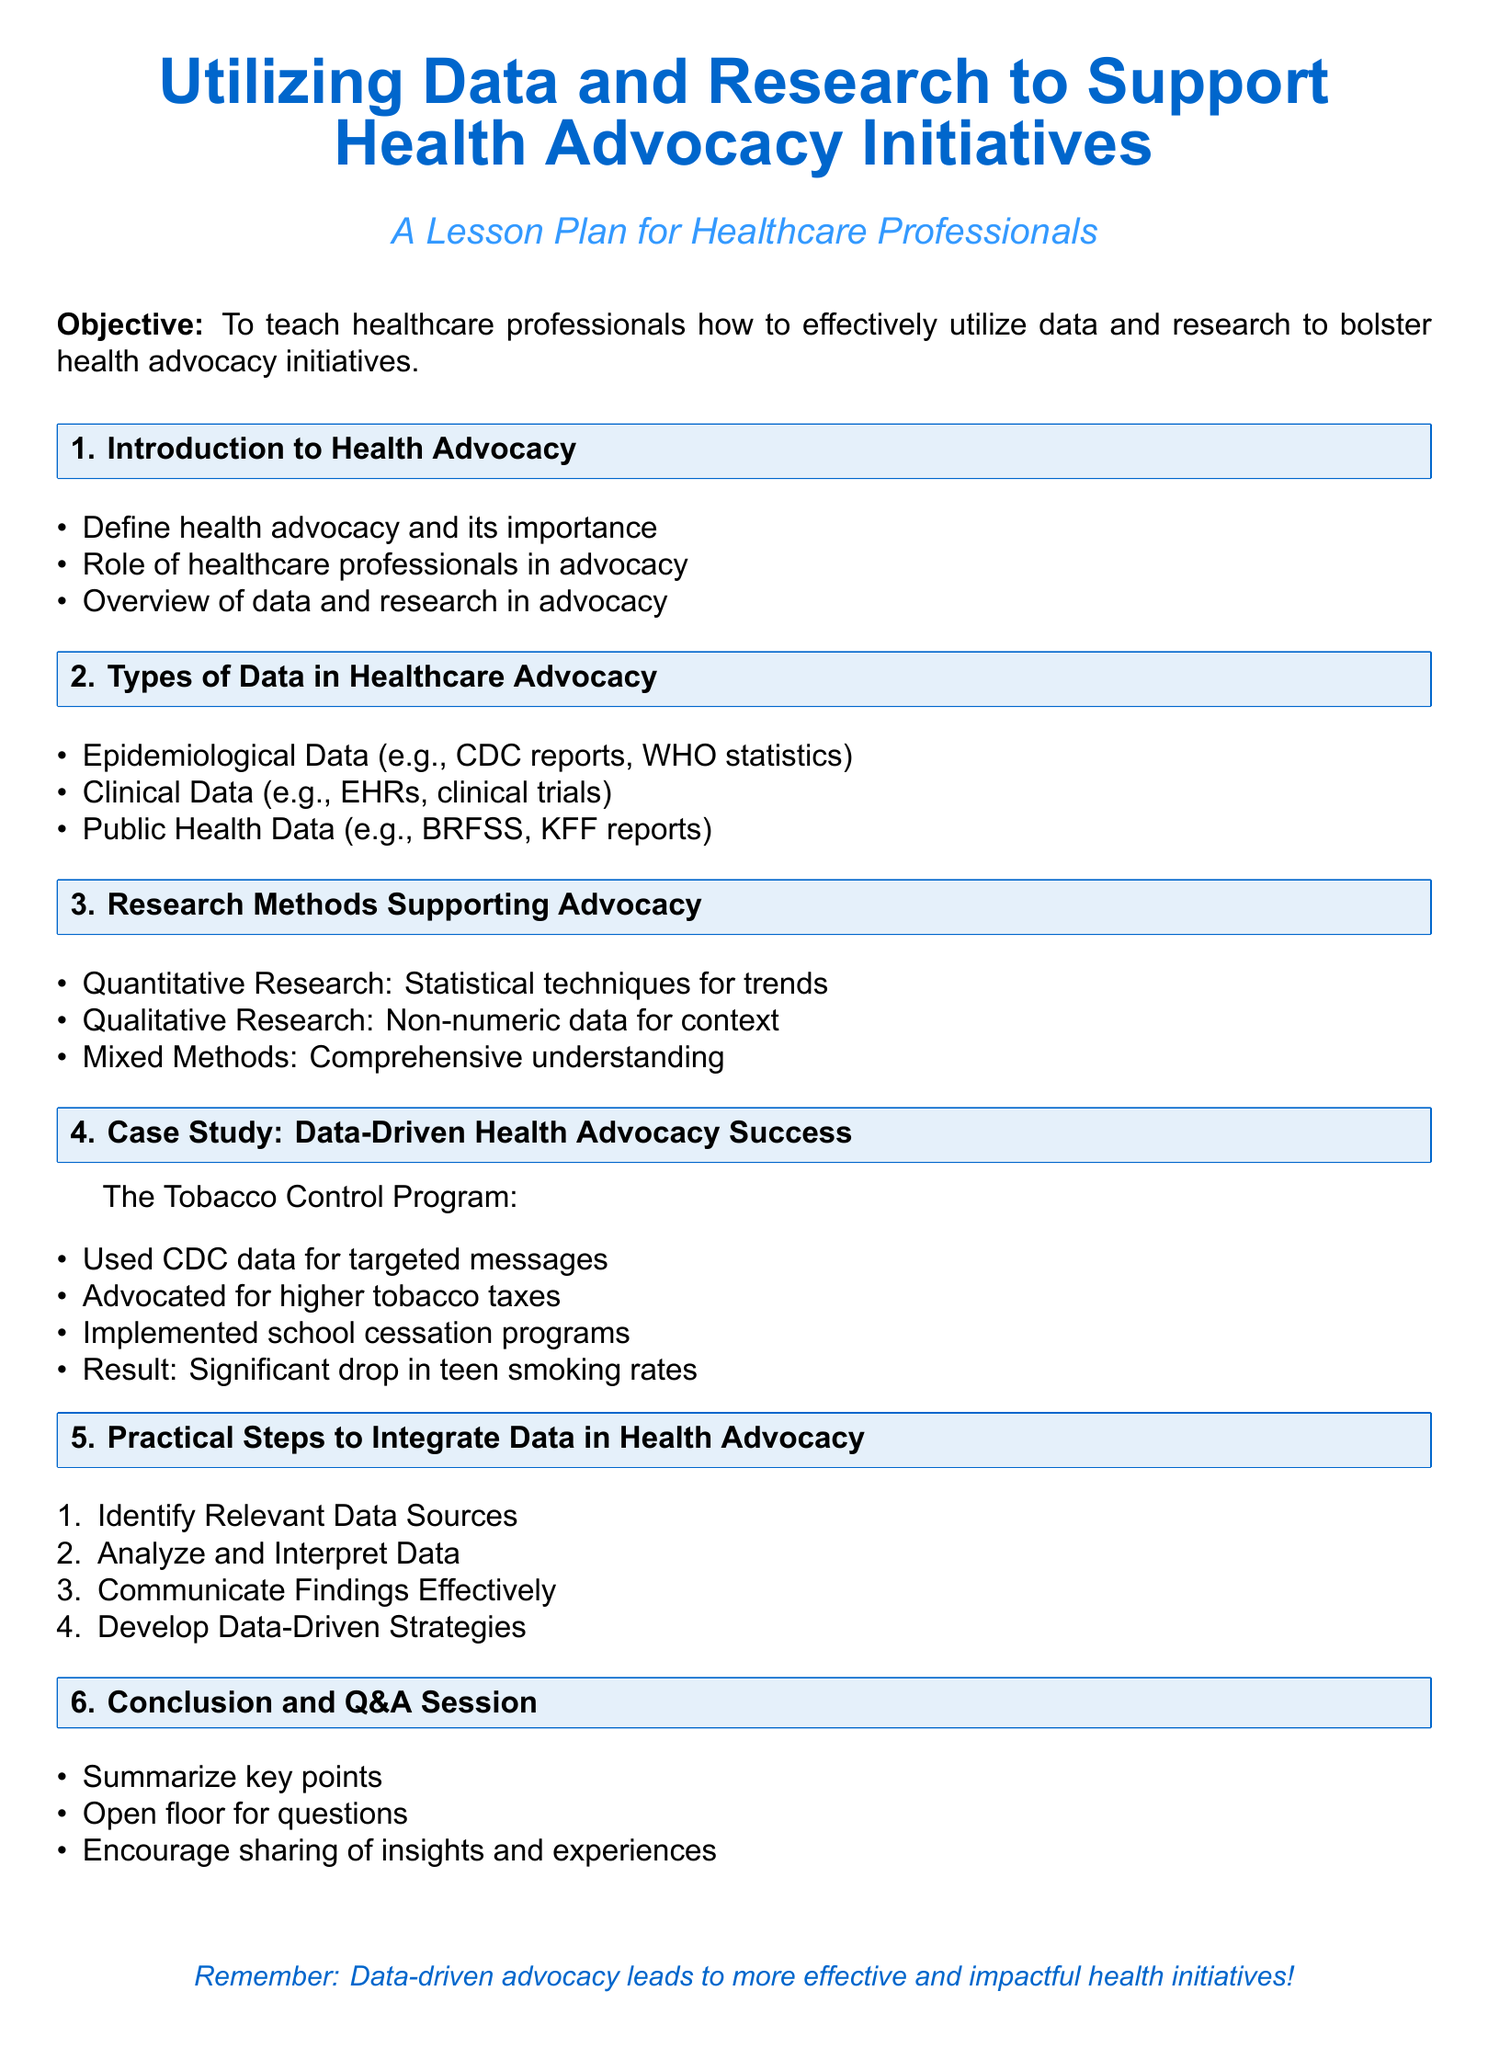What is the objective of the lesson plan? The objective is stated as teaching healthcare professionals how to effectively utilize data and research to bolster health advocacy initiatives.
Answer: To teach healthcare professionals how to effectively utilize data and research to bolster health advocacy initiatives What type of data includes CDC reports? The document classifies epidemiological data as including CDC reports.
Answer: Epidemiological Data What success case is discussed in the document? The case study highlighted in the document is the Tobacco Control Program.
Answer: The Tobacco Control Program What is one of the practical steps to integrate data in health advocacy? The practical steps include identifying relevant data sources.
Answer: Identify Relevant Data Sources How many types of research methods supporting advocacy are mentioned? The document lists three types of research methods: quantitative, qualitative, and mixed.
Answer: Three Which section discusses the role of healthcare professionals? The role of healthcare professionals is discussed in the Introduction to Health Advocacy section.
Answer: Introduction to Health Advocacy What was a result of the Tobacco Control Program? The document states a significant drop in teen smoking rates as a result of the program.
Answer: Significant drop in teen smoking rates What is the color theme used for the title? The color theme used for the title is a specific shade of blue defined as maincolor and seccolor.
Answer: Blue 